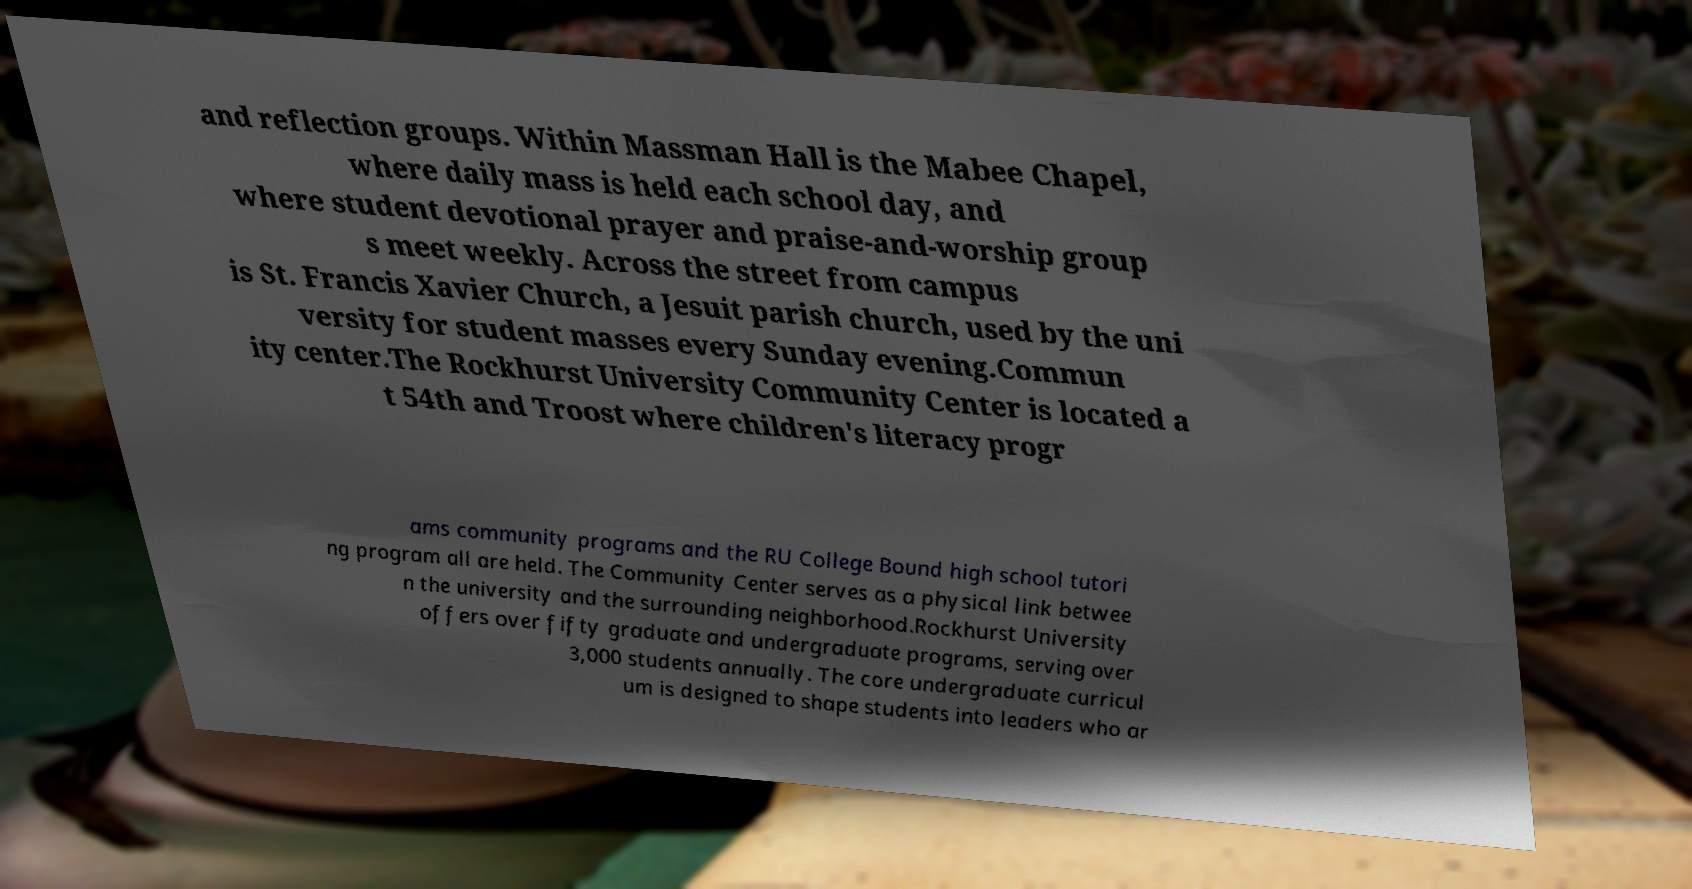For documentation purposes, I need the text within this image transcribed. Could you provide that? and reflection groups. Within Massman Hall is the Mabee Chapel, where daily mass is held each school day, and where student devotional prayer and praise-and-worship group s meet weekly. Across the street from campus is St. Francis Xavier Church, a Jesuit parish church, used by the uni versity for student masses every Sunday evening.Commun ity center.The Rockhurst University Community Center is located a t 54th and Troost where children's literacy progr ams community programs and the RU College Bound high school tutori ng program all are held. The Community Center serves as a physical link betwee n the university and the surrounding neighborhood.Rockhurst University offers over fifty graduate and undergraduate programs, serving over 3,000 students annually. The core undergraduate curricul um is designed to shape students into leaders who ar 